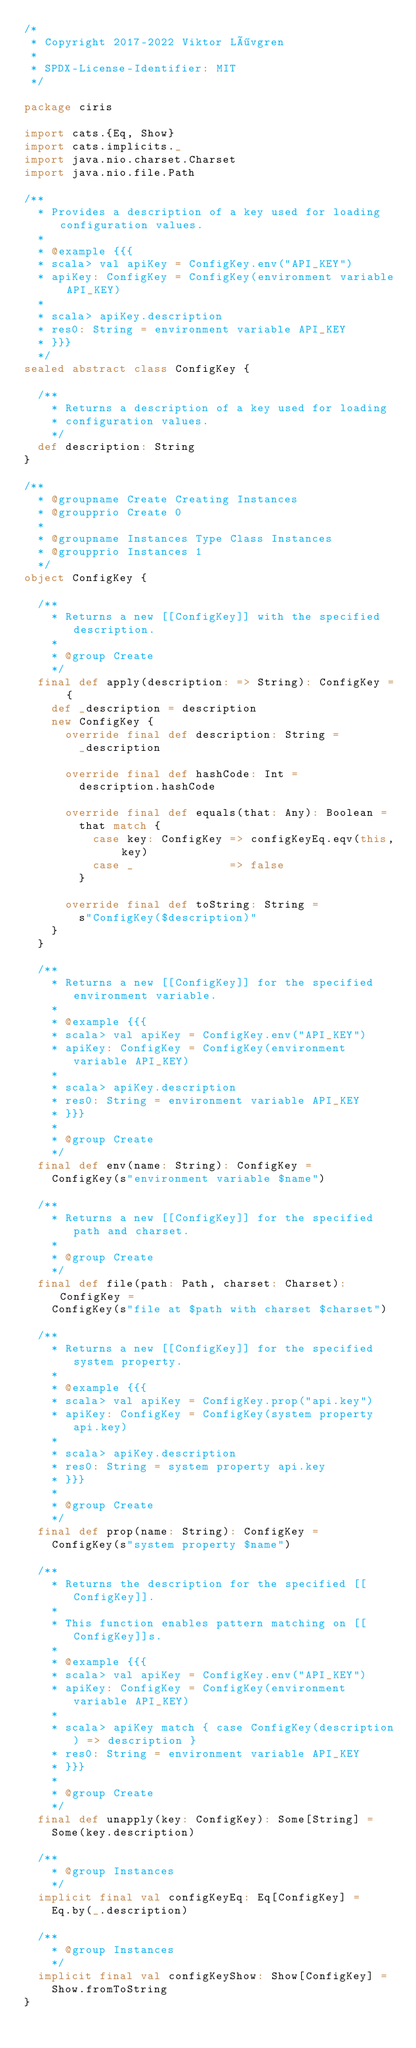<code> <loc_0><loc_0><loc_500><loc_500><_Scala_>/*
 * Copyright 2017-2022 Viktor Lövgren
 *
 * SPDX-License-Identifier: MIT
 */

package ciris

import cats.{Eq, Show}
import cats.implicits._
import java.nio.charset.Charset
import java.nio.file.Path

/**
  * Provides a description of a key used for loading configuration values.
  *
  * @example {{{
  * scala> val apiKey = ConfigKey.env("API_KEY")
  * apiKey: ConfigKey = ConfigKey(environment variable API_KEY)
  *
  * scala> apiKey.description
  * res0: String = environment variable API_KEY
  * }}}
  */
sealed abstract class ConfigKey {

  /**
    * Returns a description of a key used for loading
    * configuration values.
    */
  def description: String
}

/**
  * @groupname Create Creating Instances
  * @groupprio Create 0
  *
  * @groupname Instances Type Class Instances
  * @groupprio Instances 1
  */
object ConfigKey {

  /**
    * Returns a new [[ConfigKey]] with the specified description.
    *
    * @group Create
    */
  final def apply(description: => String): ConfigKey = {
    def _description = description
    new ConfigKey {
      override final def description: String =
        _description

      override final def hashCode: Int =
        description.hashCode

      override final def equals(that: Any): Boolean =
        that match {
          case key: ConfigKey => configKeyEq.eqv(this, key)
          case _              => false
        }

      override final def toString: String =
        s"ConfigKey($description)"
    }
  }

  /**
    * Returns a new [[ConfigKey]] for the specified environment variable.
    *
    * @example {{{
    * scala> val apiKey = ConfigKey.env("API_KEY")
    * apiKey: ConfigKey = ConfigKey(environment variable API_KEY)
    *
    * scala> apiKey.description
    * res0: String = environment variable API_KEY
    * }}}
    *
    * @group Create
    */
  final def env(name: String): ConfigKey =
    ConfigKey(s"environment variable $name")

  /**
    * Returns a new [[ConfigKey]] for the specified path and charset.
    *
    * @group Create
    */
  final def file(path: Path, charset: Charset): ConfigKey =
    ConfigKey(s"file at $path with charset $charset")

  /**
    * Returns a new [[ConfigKey]] for the specified system property.
    *
    * @example {{{
    * scala> val apiKey = ConfigKey.prop("api.key")
    * apiKey: ConfigKey = ConfigKey(system property api.key)
    *
    * scala> apiKey.description
    * res0: String = system property api.key
    * }}}
    *
    * @group Create
    */
  final def prop(name: String): ConfigKey =
    ConfigKey(s"system property $name")

  /**
    * Returns the description for the specified [[ConfigKey]].
    *
    * This function enables pattern matching on [[ConfigKey]]s.
    *
    * @example {{{
    * scala> val apiKey = ConfigKey.env("API_KEY")
    * apiKey: ConfigKey = ConfigKey(environment variable API_KEY)
    *
    * scala> apiKey match { case ConfigKey(description) => description }
    * res0: String = environment variable API_KEY
    * }}}
    *
    * @group Create
    */
  final def unapply(key: ConfigKey): Some[String] =
    Some(key.description)

  /**
    * @group Instances
    */
  implicit final val configKeyEq: Eq[ConfigKey] =
    Eq.by(_.description)

  /**
    * @group Instances
    */
  implicit final val configKeyShow: Show[ConfigKey] =
    Show.fromToString
}
</code> 